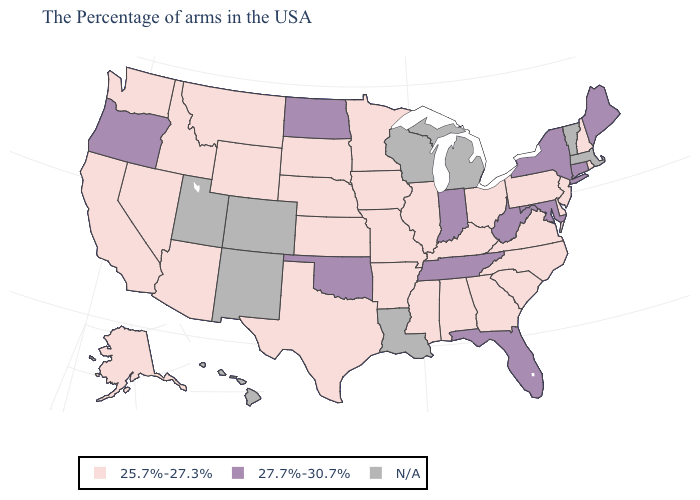Name the states that have a value in the range N/A?
Write a very short answer. Massachusetts, Vermont, Michigan, Wisconsin, Louisiana, Colorado, New Mexico, Utah, Hawaii. Name the states that have a value in the range 27.7%-30.7%?
Keep it brief. Maine, Connecticut, New York, Maryland, West Virginia, Florida, Indiana, Tennessee, Oklahoma, North Dakota, Oregon. What is the value of Kansas?
Write a very short answer. 25.7%-27.3%. Name the states that have a value in the range 25.7%-27.3%?
Be succinct. Rhode Island, New Hampshire, New Jersey, Delaware, Pennsylvania, Virginia, North Carolina, South Carolina, Ohio, Georgia, Kentucky, Alabama, Illinois, Mississippi, Missouri, Arkansas, Minnesota, Iowa, Kansas, Nebraska, Texas, South Dakota, Wyoming, Montana, Arizona, Idaho, Nevada, California, Washington, Alaska. What is the value of Ohio?
Answer briefly. 25.7%-27.3%. Does the first symbol in the legend represent the smallest category?
Concise answer only. Yes. What is the lowest value in states that border Wyoming?
Be succinct. 25.7%-27.3%. Name the states that have a value in the range 27.7%-30.7%?
Be succinct. Maine, Connecticut, New York, Maryland, West Virginia, Florida, Indiana, Tennessee, Oklahoma, North Dakota, Oregon. Among the states that border Connecticut , does New York have the lowest value?
Answer briefly. No. Among the states that border Indiana , which have the lowest value?
Answer briefly. Ohio, Kentucky, Illinois. Name the states that have a value in the range 25.7%-27.3%?
Keep it brief. Rhode Island, New Hampshire, New Jersey, Delaware, Pennsylvania, Virginia, North Carolina, South Carolina, Ohio, Georgia, Kentucky, Alabama, Illinois, Mississippi, Missouri, Arkansas, Minnesota, Iowa, Kansas, Nebraska, Texas, South Dakota, Wyoming, Montana, Arizona, Idaho, Nevada, California, Washington, Alaska. What is the value of South Carolina?
Give a very brief answer. 25.7%-27.3%. What is the value of Louisiana?
Be succinct. N/A. 